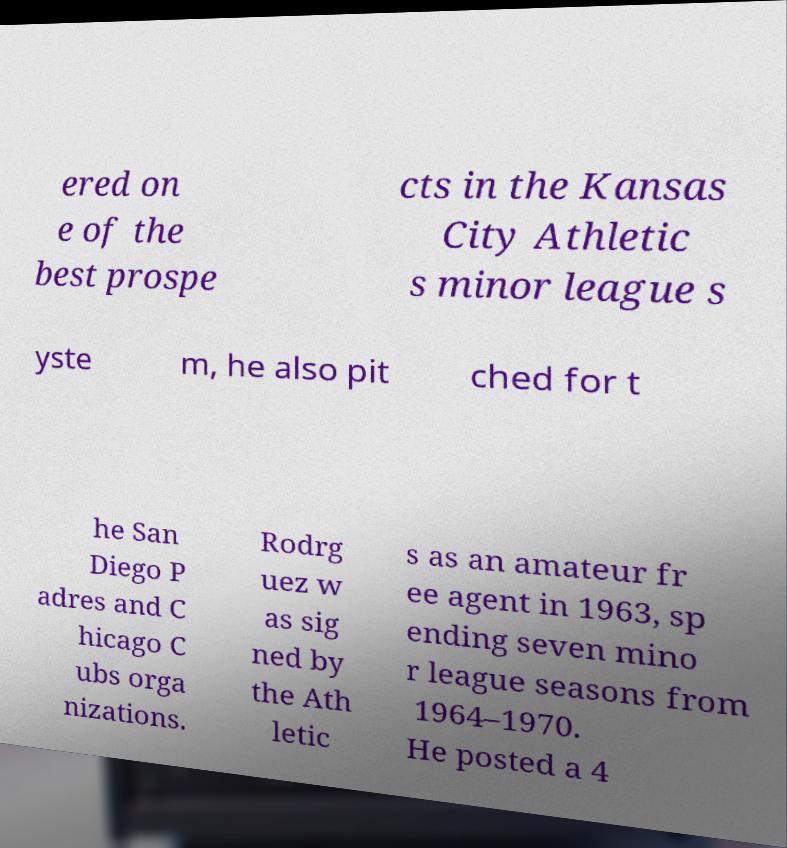Can you accurately transcribe the text from the provided image for me? ered on e of the best prospe cts in the Kansas City Athletic s minor league s yste m, he also pit ched for t he San Diego P adres and C hicago C ubs orga nizations. Rodrg uez w as sig ned by the Ath letic s as an amateur fr ee agent in 1963, sp ending seven mino r league seasons from 1964–1970. He posted a 4 